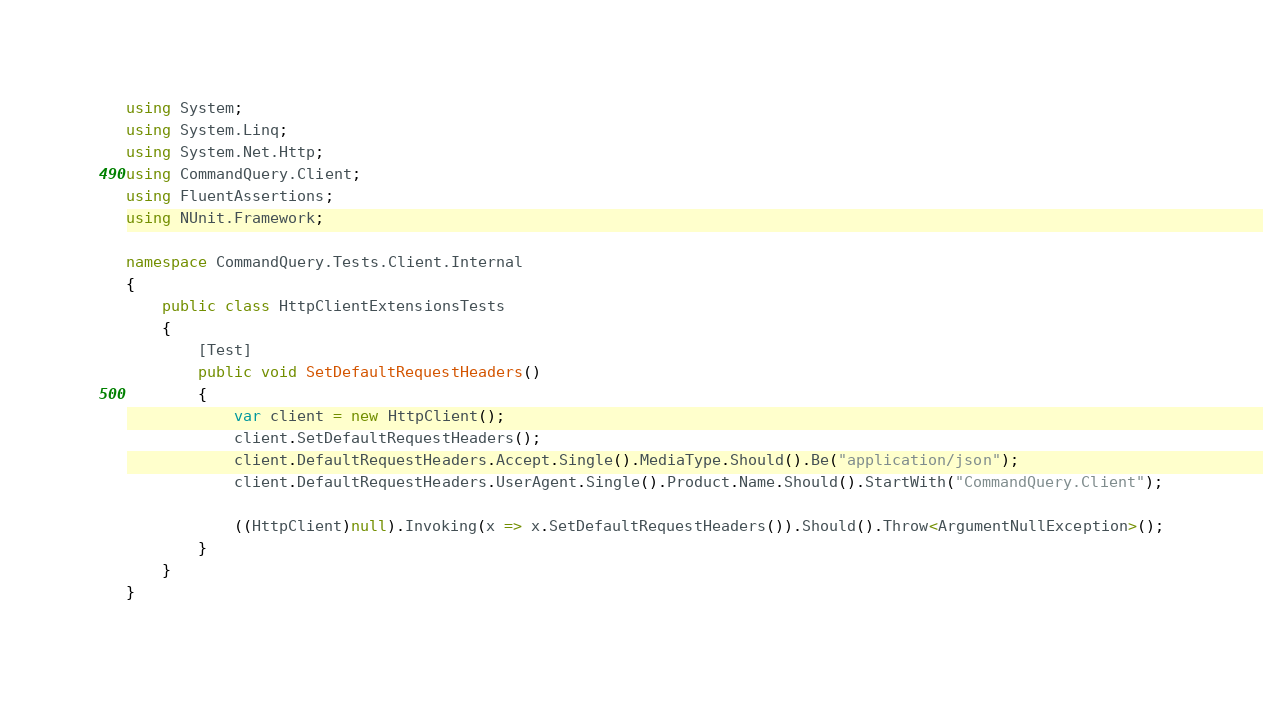<code> <loc_0><loc_0><loc_500><loc_500><_C#_>using System;
using System.Linq;
using System.Net.Http;
using CommandQuery.Client;
using FluentAssertions;
using NUnit.Framework;

namespace CommandQuery.Tests.Client.Internal
{
    public class HttpClientExtensionsTests
    {
        [Test]
        public void SetDefaultRequestHeaders()
        {
            var client = new HttpClient();
            client.SetDefaultRequestHeaders();
            client.DefaultRequestHeaders.Accept.Single().MediaType.Should().Be("application/json");
            client.DefaultRequestHeaders.UserAgent.Single().Product.Name.Should().StartWith("CommandQuery.Client");

            ((HttpClient)null).Invoking(x => x.SetDefaultRequestHeaders()).Should().Throw<ArgumentNullException>();
        }
    }
}
</code> 